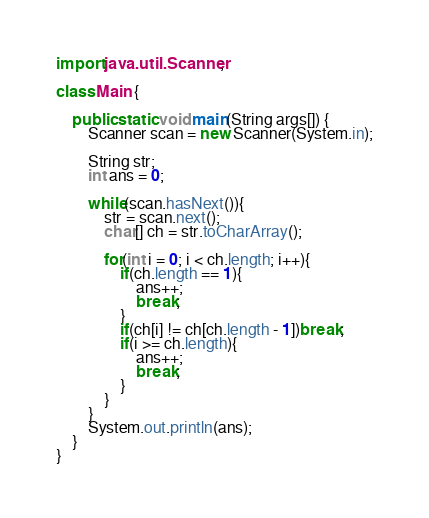Convert code to text. <code><loc_0><loc_0><loc_500><loc_500><_Java_>import java.util.Scanner;

class Main {

	public static void main(String args[]) {
		Scanner scan = new Scanner(System.in);
		
		String str;
		int ans = 0;
		
		while(scan.hasNext()){
			str = scan.next();
			char[] ch = str.toCharArray();
			
			for(int i = 0; i < ch.length; i++){
				if(ch.length == 1){
					ans++;
					break;
				}
				if(ch[i] != ch[ch.length - 1])break;
				if(i >= ch.length){
					ans++;
					break;
				}
			}
		}
		System.out.println(ans);
	}
}</code> 